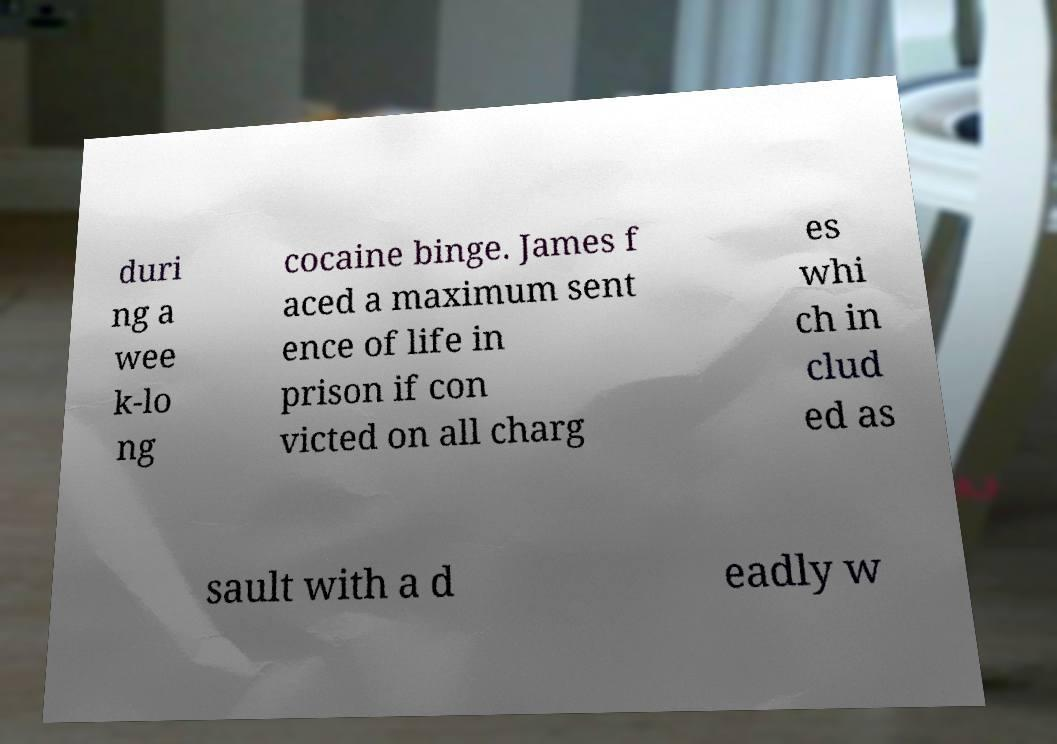Could you assist in decoding the text presented in this image and type it out clearly? duri ng a wee k-lo ng cocaine binge. James f aced a maximum sent ence of life in prison if con victed on all charg es whi ch in clud ed as sault with a d eadly w 